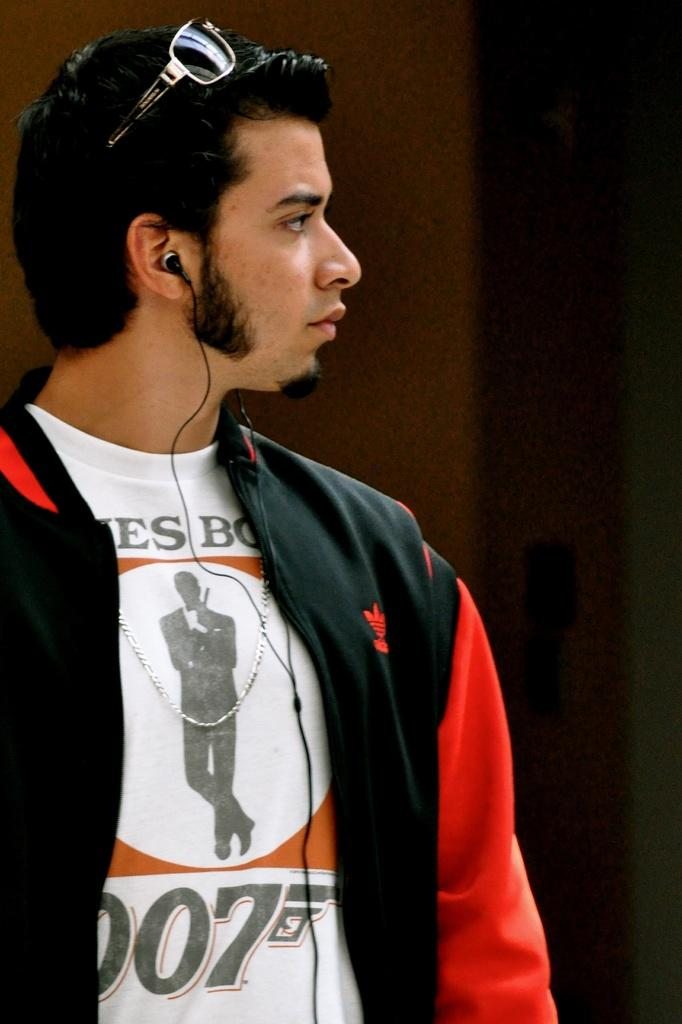Who or what is the main subject of the image? There is a person in the image. Can you describe the person's attire? The person is wearing a dress with white, black, and red colors. What is the person doing in the image? The person is standing. What colors can be seen in the background of the image? The background of the image is brown and black colored. How many receipts are visible in the image? There are no receipts present in the image. What is the size of the person's brothers in the image? There is no mention of the person having brothers in the image, so their size cannot be determined. 